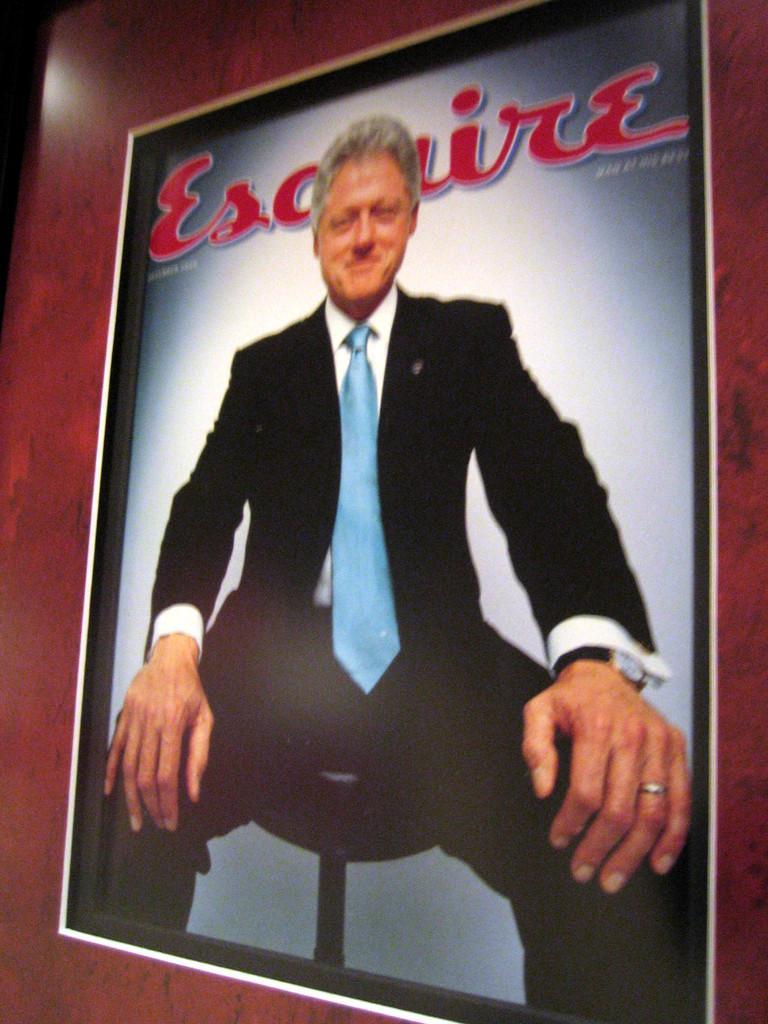Could you give a brief overview of what you see in this image? In this picture we can see a photo frame, there is a picture of a man and some text in the frame. 